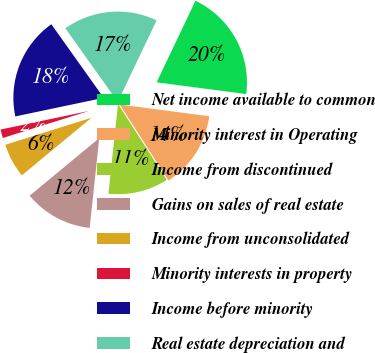<chart> <loc_0><loc_0><loc_500><loc_500><pie_chart><fcel>Net income available to common<fcel>Minority interest in Operating<fcel>Income from discontinued<fcel>Gains on sales of real estate<fcel>Income from unconsolidated<fcel>Minority interests in property<fcel>Income before minority<fcel>Real estate depreciation and<nl><fcel>20.0%<fcel>13.85%<fcel>10.77%<fcel>12.31%<fcel>6.16%<fcel>1.54%<fcel>18.46%<fcel>16.92%<nl></chart> 